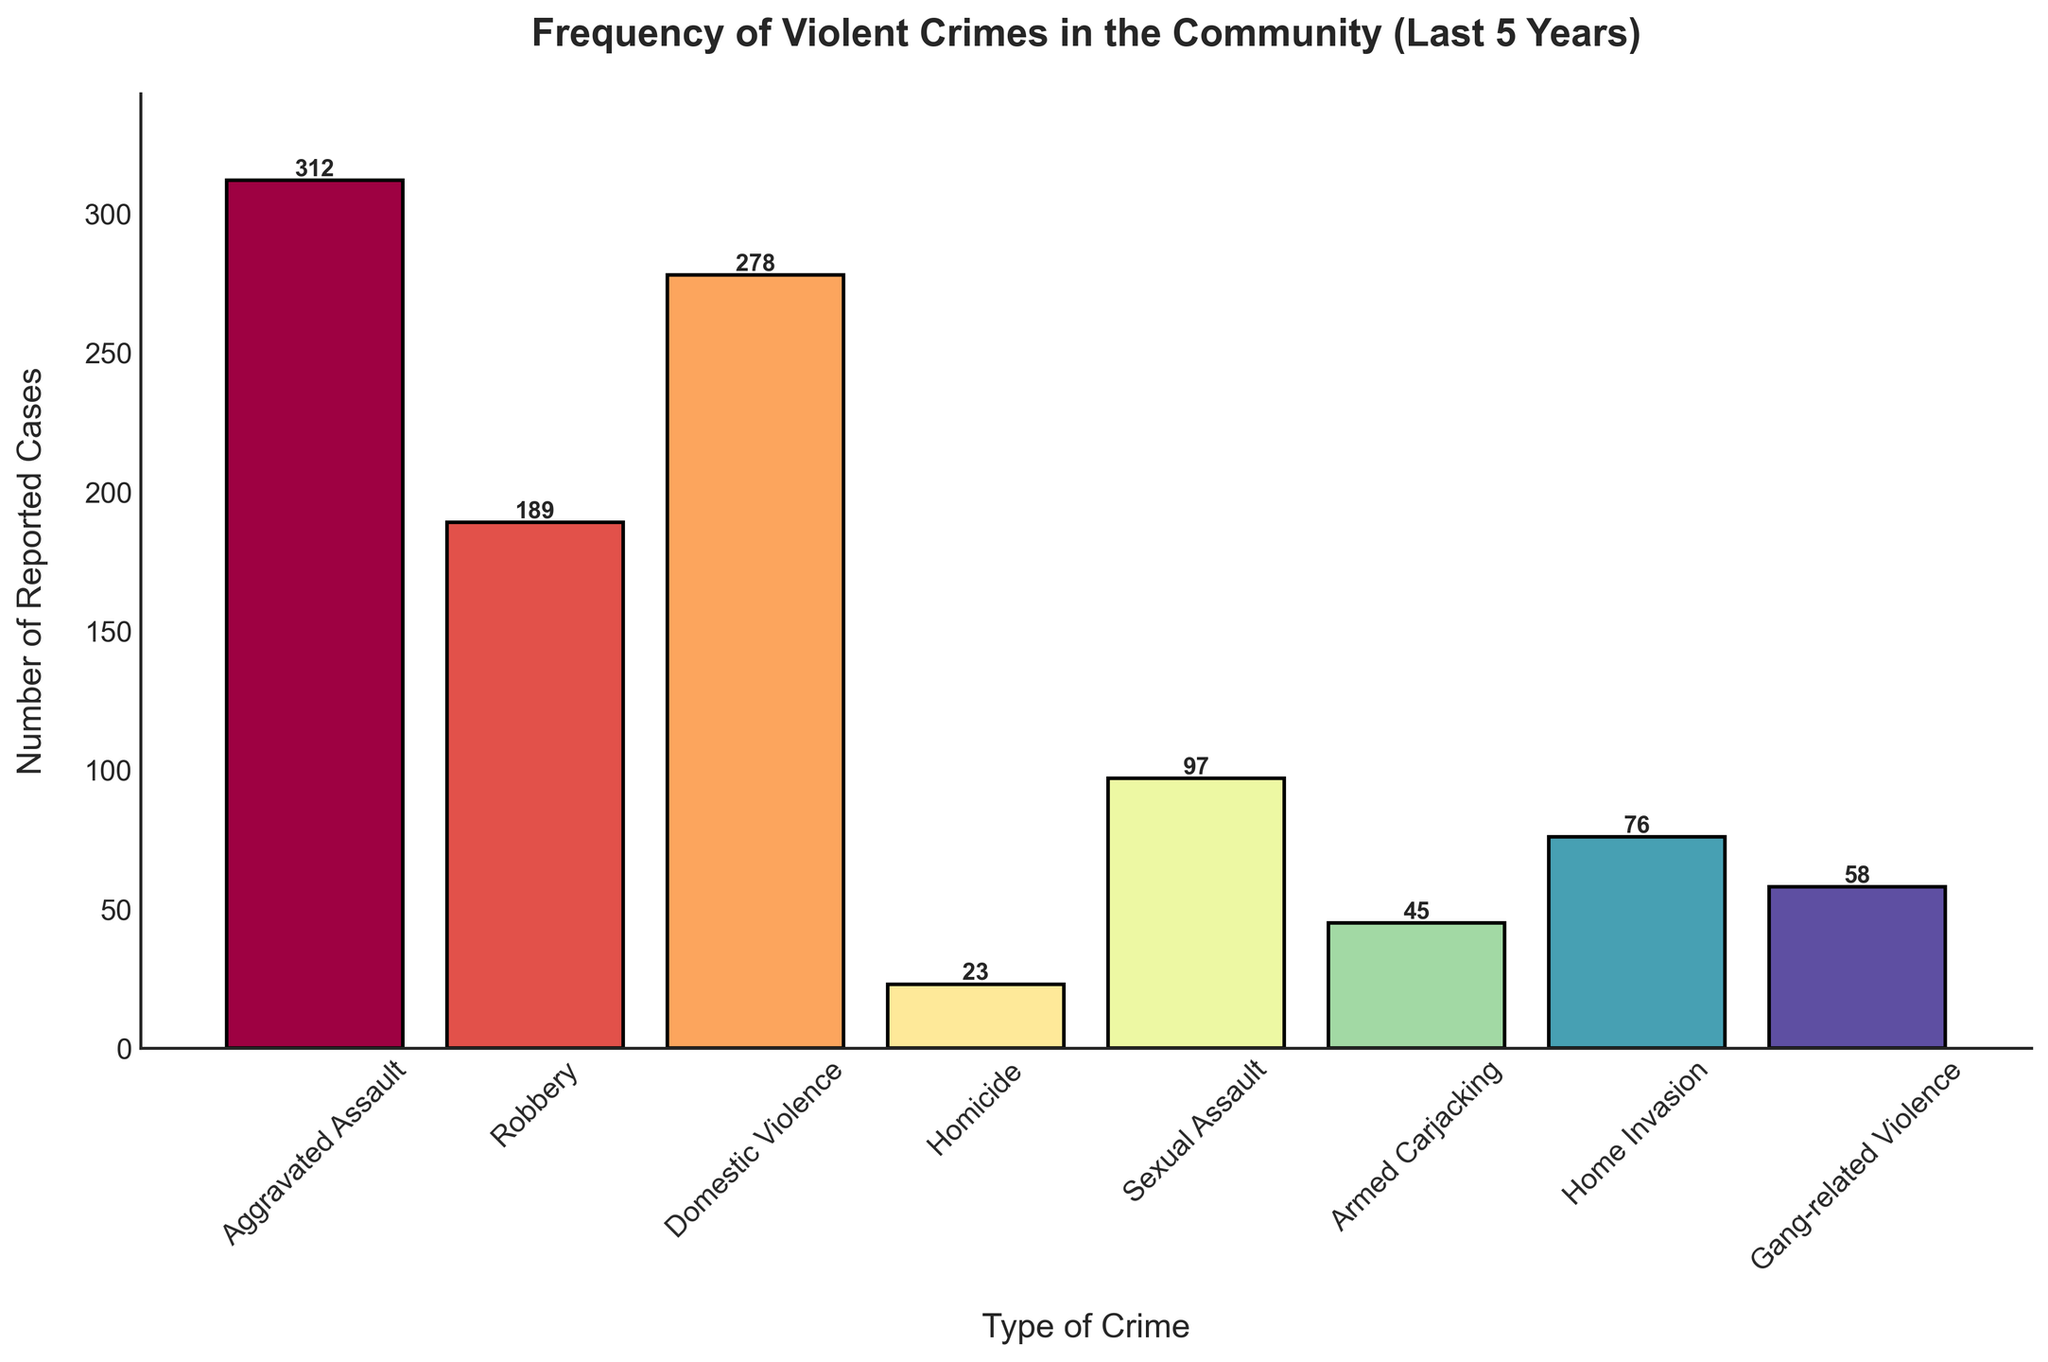What is the title of the figure? The title of the figure is located at the top and describes the overall content, which is "Frequency of Violent Crimes in the Community (Last 5 Years)"
Answer: Frequency of Violent Crimes in the Community (Last 5 Years) Which type of violent crime has the highest number of reported cases? To identify the violent crime with the highest reported cases, look for the tallest bar. The tallest bar represents Aggravated Assault with 312 cases.
Answer: Aggravated Assault How many reported cases of Homicide are there? The number of reported cases for Homicide can be found by looking at the height of the bar corresponding to Homicide, which is 23 cases.
Answer: 23 What is the sum of reported cases for Domestic Violence and Sexual Assault? First, find the reported cases for Domestic Violence (278) and Sexual Assault (97), then add them together: 278 + 97 = 375
Answer: 375 Which type of crime has fewer reported cases: Armed Carjacking or Home Invasion? Compare the heights of the bars for Armed Carjacking (45 cases) and Home Invasion (76 cases). Armed Carjacking has fewer reported cases.
Answer: Armed Carjacking How many types of violent crimes are shown in the figure? Count the number of different bars representing different crime types in the histogram. There are 8 types of violent crimes.
Answer: 8 Is Robbery reported more frequently than Home Invasion? Compare the heights of the bars for Robbery (189 cases) and Home Invasion (76 cases). Robbery has more reported cases.
Answer: Yes What is the difference in reported cases between Aggravated Assault and Homicide? Subtract the number of reported cases for Homicide (23) from the number of reported cases for Aggravated Assault (312): 312 - 23 = 289
Answer: 289 What’s the average number of cases reported for Gang-related Violence and Home Invasion? First, find the reported cases for Gang-related Violence (58) and Home Invasion (76), then calculate the average by adding them and dividing by 2: (58 + 76) / 2 = 67
Answer: 67 Which types of crime have reported cases less than 100? Identify bars with heights less than 100. These are Homicide (23 cases), Sexual Assault (97 cases), Armed Carjacking (45 cases), Home Invasion (76 cases), and Gang-related Violence (58 cases).
Answer: Homicide, Sexual Assault, Armed Carjacking, Home Invasion, Gang-related Violence 